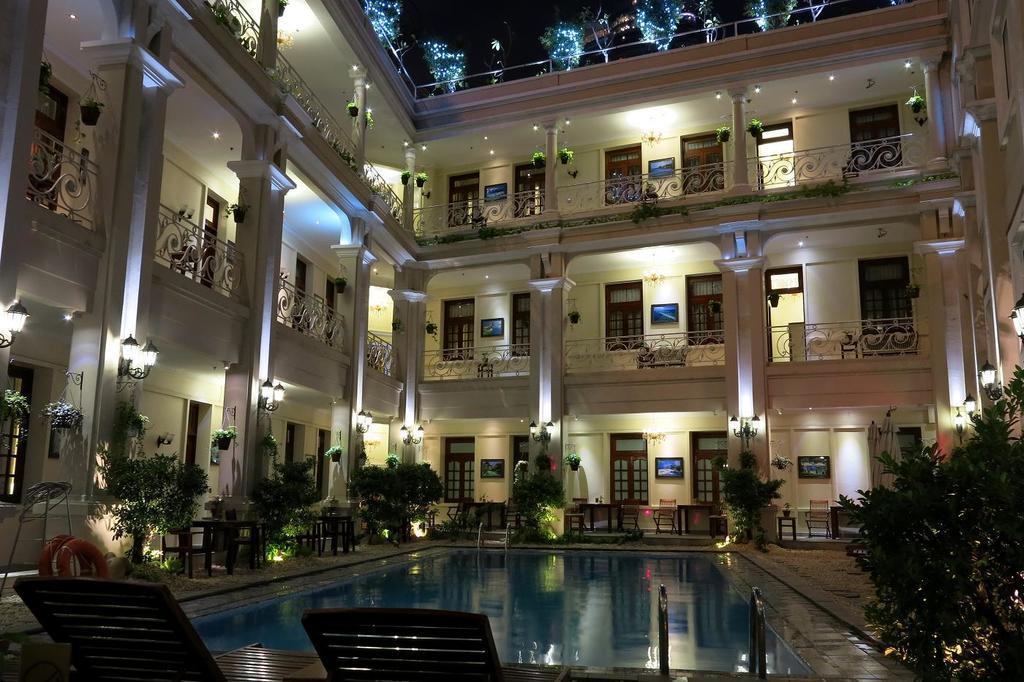Describe this image in one or two sentences. In this picture we can see chairs, swimming pool, trees, house plants, tables, swim tubes, frames on the wall, pillars and a building with windows and some objects. 